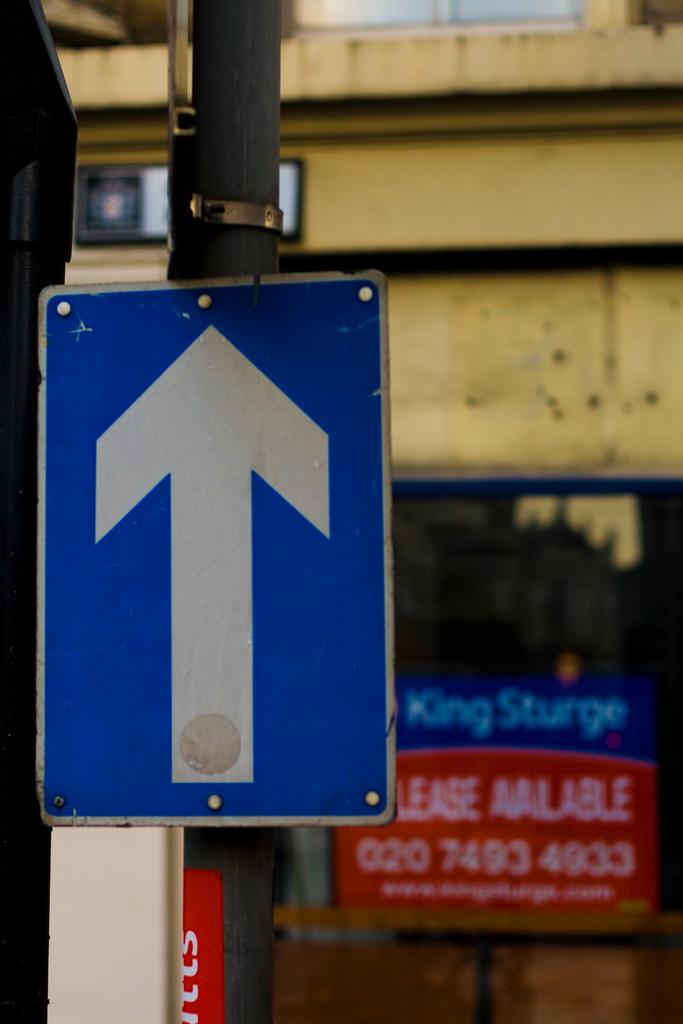What is  the phone number to call for king sturge?
Your response must be concise. 02074934933. What is the name of the king on the blue board?
Make the answer very short. Sturge. 